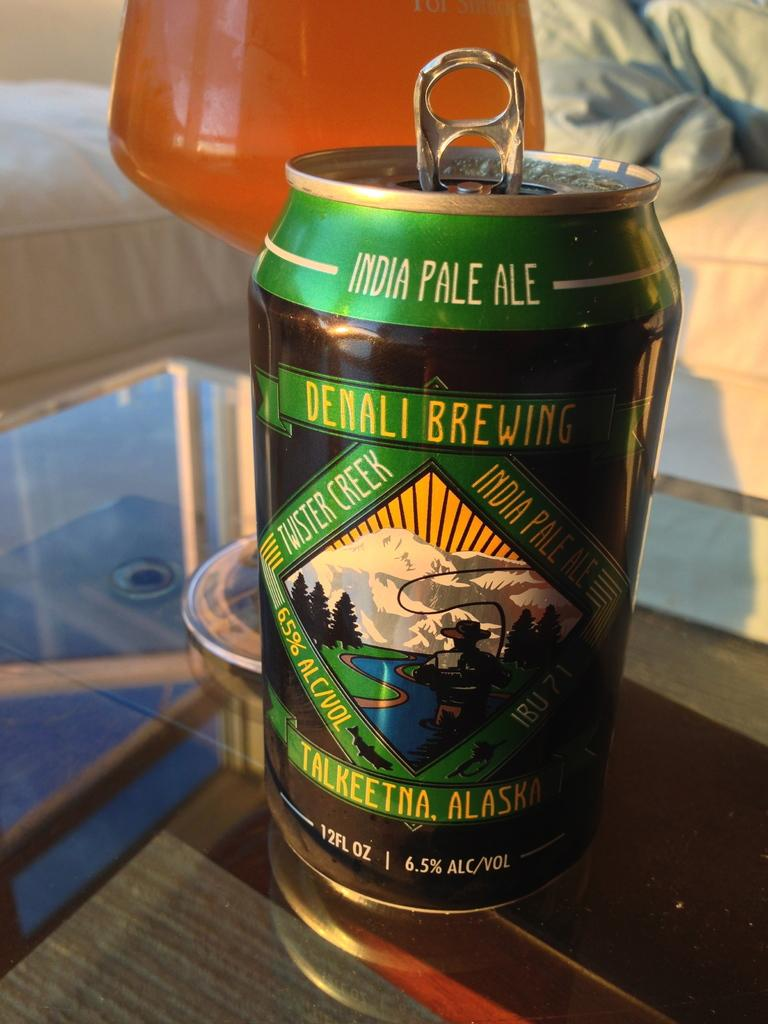<image>
Offer a succinct explanation of the picture presented. Denali Brewing is advertised on a green can of pale ale. 